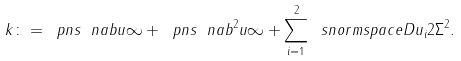Convert formula to latex. <formula><loc_0><loc_0><loc_500><loc_500>\ k \colon = \ p n s { \ n a b u } { \infty } + \ p n s { \ n a b ^ { 2 } u } { \infty } + \sum _ { i = 1 } ^ { 2 } \ s n o r m s p a c e { D u _ { i } } { 2 } { \Sigma } ^ { 2 } .</formula> 